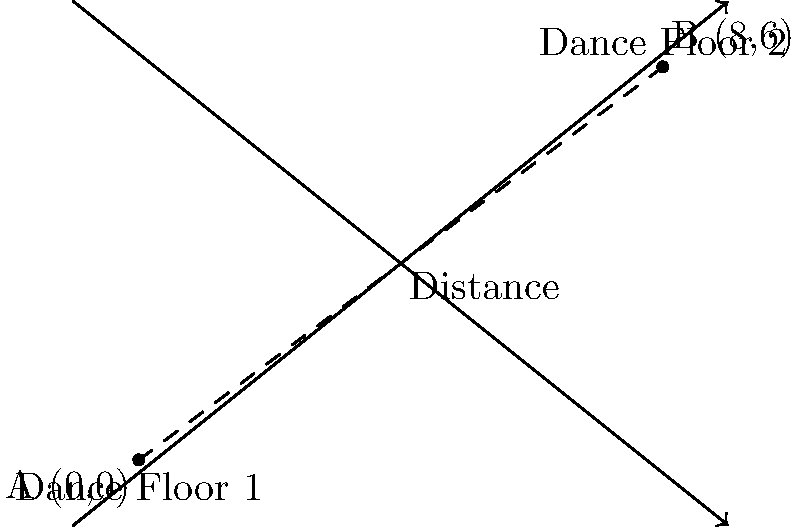As a club owner, you're planning a new layout for your next themed party. You want to calculate the distance between two dance floors to ensure optimal space utilization. Dance Floor 1 is located at coordinates (0,0), and Dance Floor 2 is at (8,6) on your club's grid system. Using the distance formula, calculate the distance between these two dance floors. To solve this problem, we'll use the distance formula between two points in a 2D plane:

$$ d = \sqrt{(x_2 - x_1)^2 + (y_2 - y_1)^2} $$

Where $(x_1, y_1)$ are the coordinates of Dance Floor 1, and $(x_2, y_2)$ are the coordinates of Dance Floor 2.

Step 1: Identify the coordinates
Dance Floor 1: $(x_1, y_1) = (0, 0)$
Dance Floor 2: $(x_2, y_2) = (8, 6)$

Step 2: Plug the values into the distance formula
$$ d = \sqrt{(8 - 0)^2 + (6 - 0)^2} $$

Step 3: Simplify the expressions inside the parentheses
$$ d = \sqrt{8^2 + 6^2} $$

Step 4: Calculate the squares
$$ d = \sqrt{64 + 36} $$

Step 5: Add the values under the square root
$$ d = \sqrt{100} $$

Step 6: Simplify the square root
$$ d = 10 $$

Therefore, the distance between the two dance floors is 10 units on your club's grid system.
Answer: 10 units 